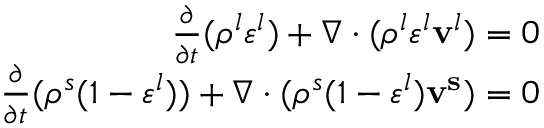Convert formula to latex. <formula><loc_0><loc_0><loc_500><loc_500>\begin{array} { r } { \frac { \partial } { \partial t } ( \rho ^ { l } \varepsilon ^ { l } ) + \nabla \cdot ( \rho ^ { l } \varepsilon ^ { l } v ^ { l } ) = 0 } \\ { \frac { \partial } { \partial t } ( \rho ^ { s } ( 1 - \varepsilon ^ { l } ) ) + \nabla \cdot ( \rho ^ { s } ( 1 - \varepsilon ^ { l } ) v ^ { s } ) = 0 } \end{array}</formula> 